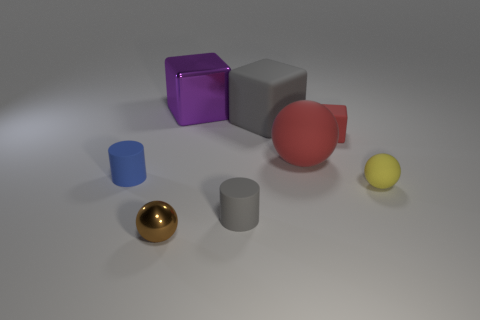Add 1 big blue metallic cylinders. How many objects exist? 9 Subtract all tiny yellow matte balls. How many balls are left? 2 Subtract all red cubes. How many cubes are left? 2 Subtract all cubes. How many objects are left? 5 Subtract all cyan blocks. How many purple balls are left? 0 Subtract all red matte things. Subtract all large purple blocks. How many objects are left? 5 Add 4 tiny blue cylinders. How many tiny blue cylinders are left? 5 Add 6 big cubes. How many big cubes exist? 8 Subtract 1 red cubes. How many objects are left? 7 Subtract 3 cubes. How many cubes are left? 0 